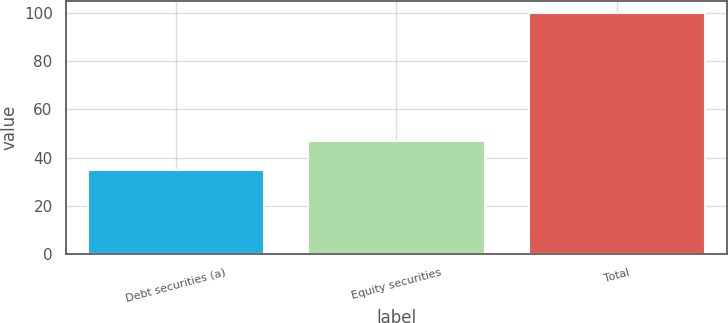Convert chart. <chart><loc_0><loc_0><loc_500><loc_500><bar_chart><fcel>Debt securities (a)<fcel>Equity securities<fcel>Total<nl><fcel>35<fcel>47<fcel>100<nl></chart> 